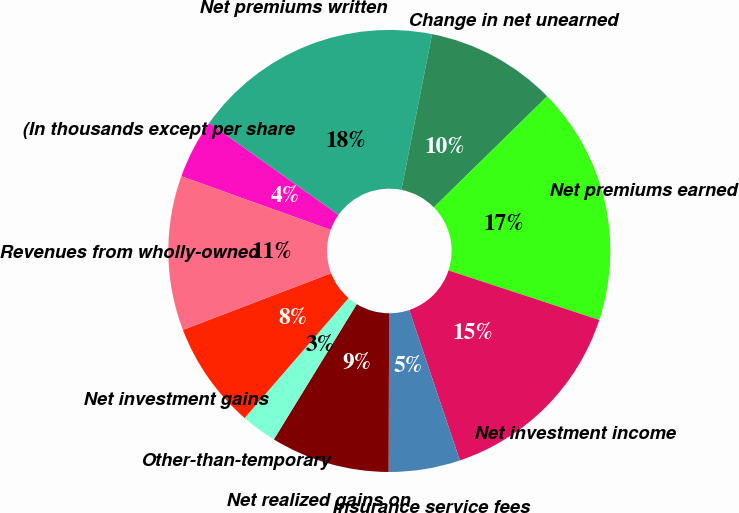<chart> <loc_0><loc_0><loc_500><loc_500><pie_chart><fcel>(In thousands except per share<fcel>Net premiums written<fcel>Change in net unearned<fcel>Net premiums earned<fcel>Net investment income<fcel>Insurance service fees<fcel>Net realized gains on<fcel>Other-than-temporary<fcel>Net investment gains<fcel>Revenues from wholly-owned<nl><fcel>4.35%<fcel>18.26%<fcel>9.57%<fcel>17.39%<fcel>14.78%<fcel>5.22%<fcel>8.7%<fcel>2.61%<fcel>7.83%<fcel>11.3%<nl></chart> 